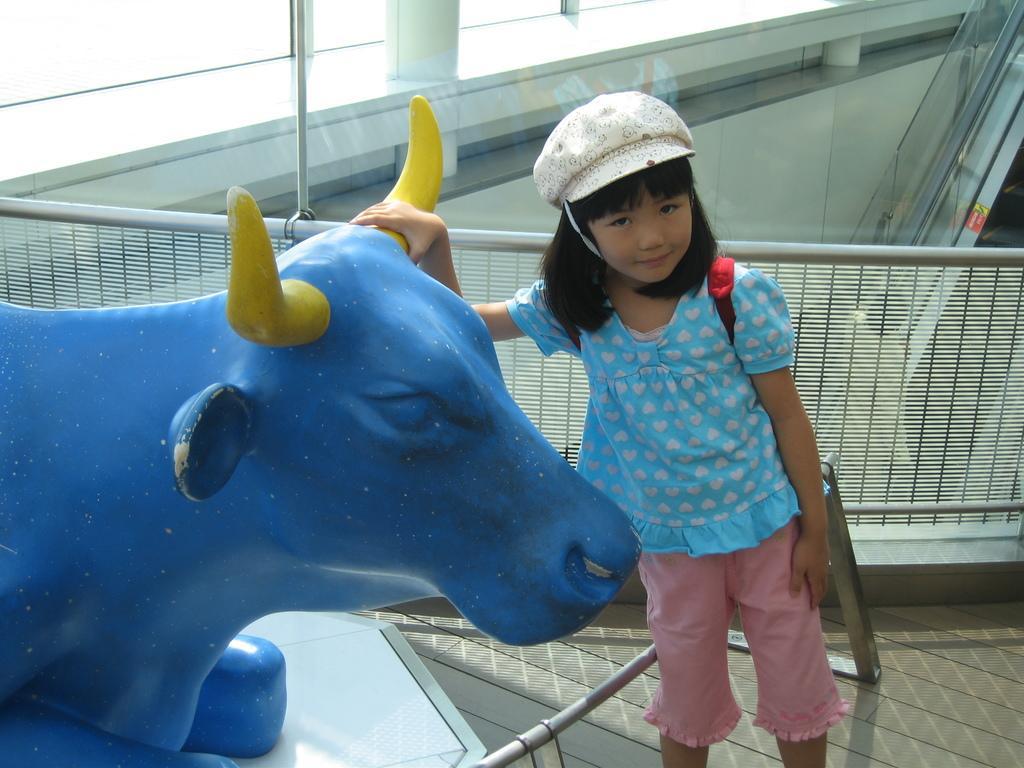How would you summarize this image in a sentence or two? In this image there is a statue of a bull. Beside the bull there is a girl. Behind her there is a metal fence. In the background of the image there are pillars. On the right side of the image there is a escalator. 